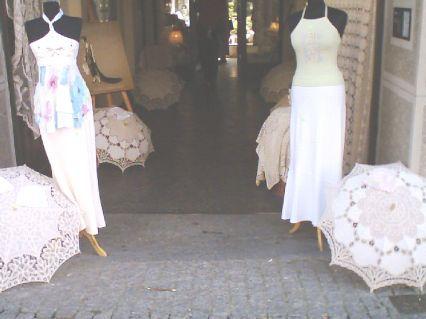Is this indoors?
Be succinct. No. Do the mannequins have arms?
Be succinct. No. Would a man be likely to come here?
Answer briefly. No. 